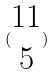Convert formula to latex. <formula><loc_0><loc_0><loc_500><loc_500>( \begin{matrix} 1 1 \\ 5 \end{matrix} )</formula> 